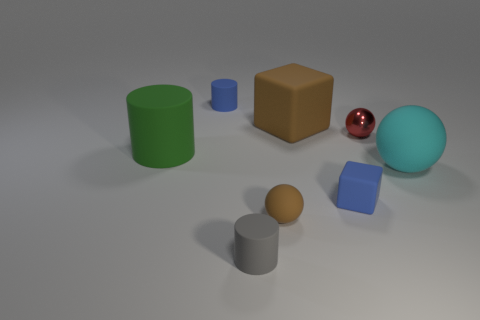Subtract 1 cylinders. How many cylinders are left? 2 Add 2 small spheres. How many objects exist? 10 Subtract all cubes. How many objects are left? 6 Subtract 1 brown blocks. How many objects are left? 7 Subtract all matte blocks. Subtract all big red rubber blocks. How many objects are left? 6 Add 1 metal balls. How many metal balls are left? 2 Add 1 small gray things. How many small gray things exist? 2 